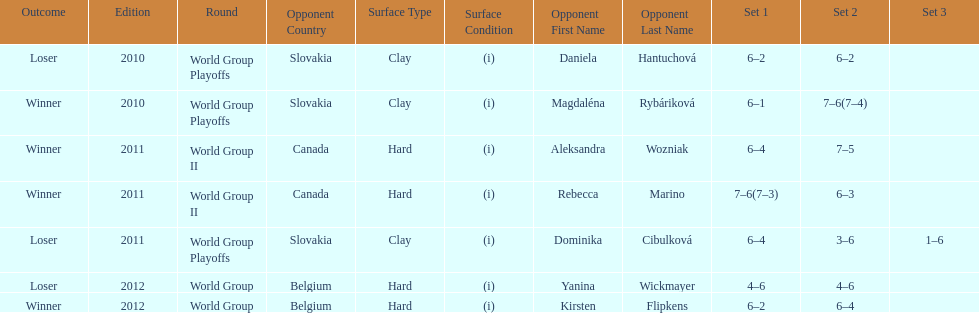Number of games in the match against dominika cibulkova? 3. 